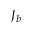<formula> <loc_0><loc_0><loc_500><loc_500>J _ { b }</formula> 